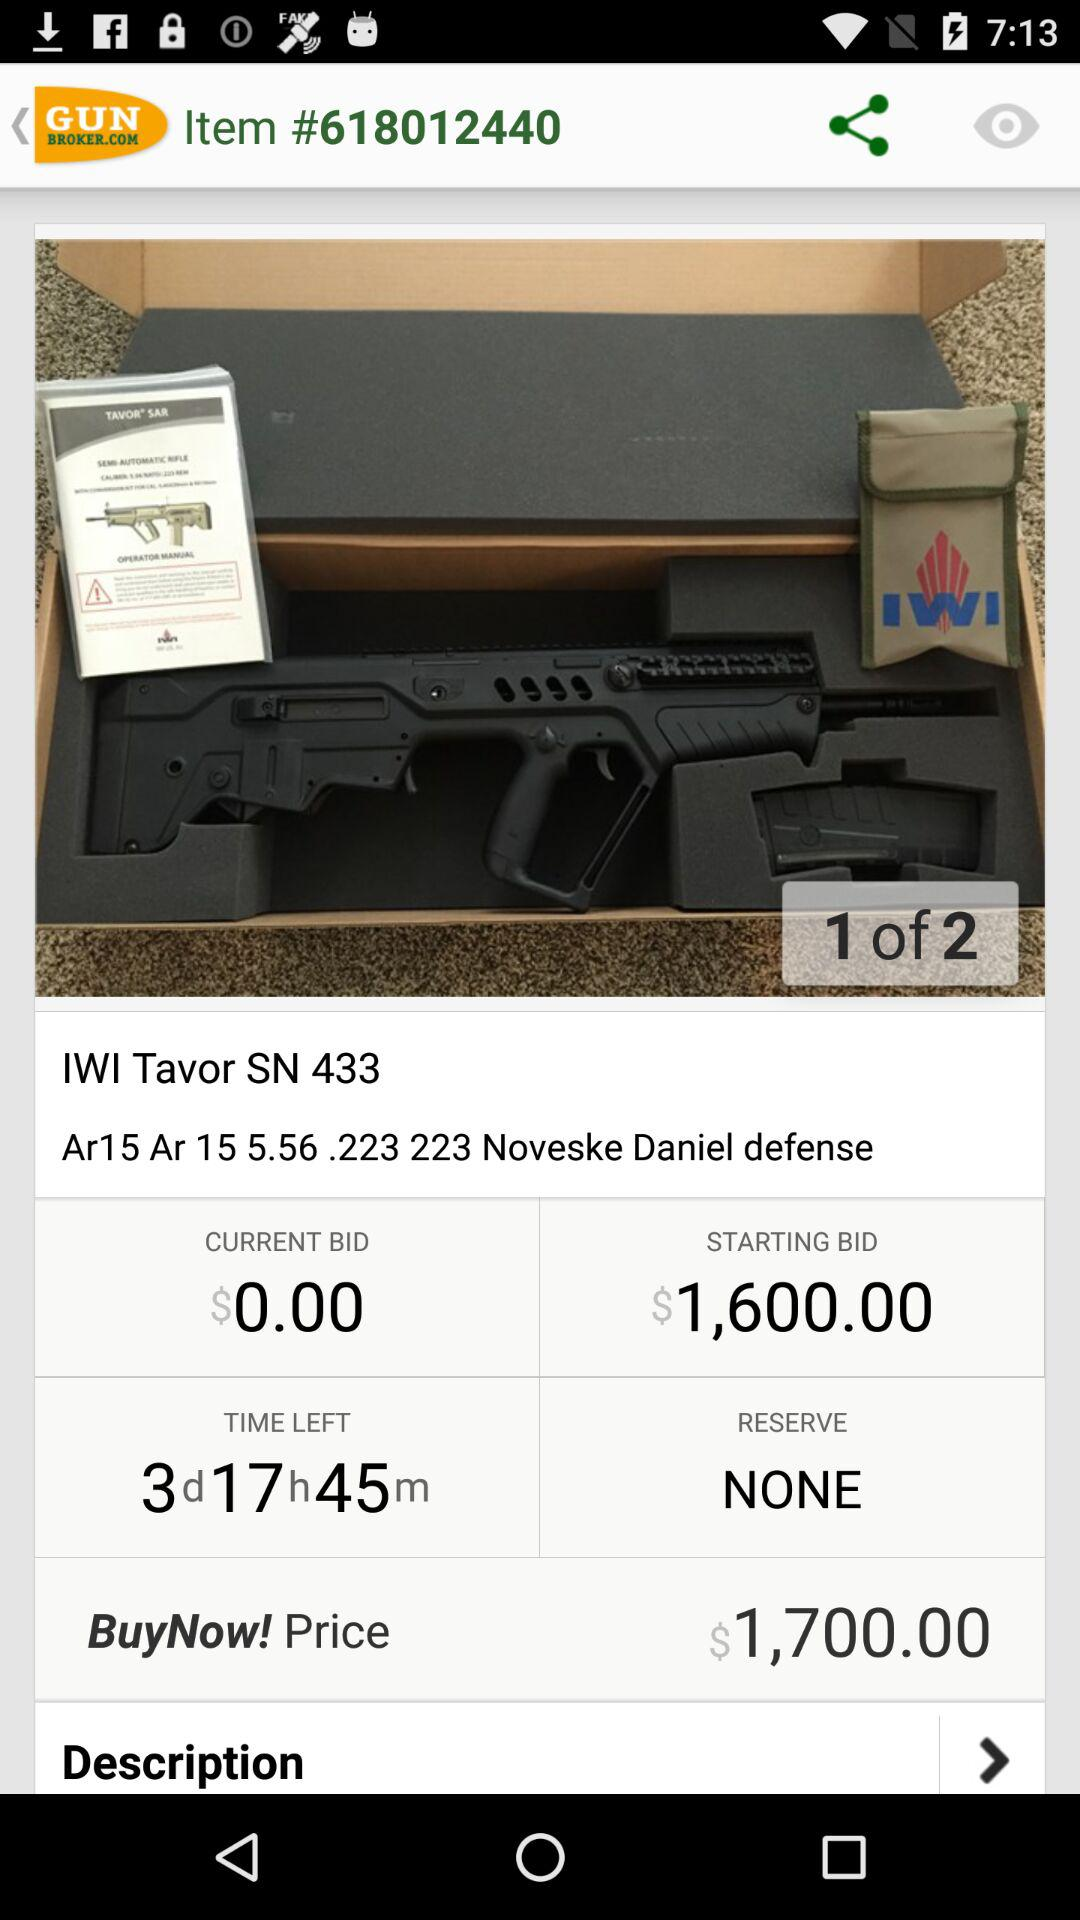What is the starting bid? The starting bid is $1,600. 